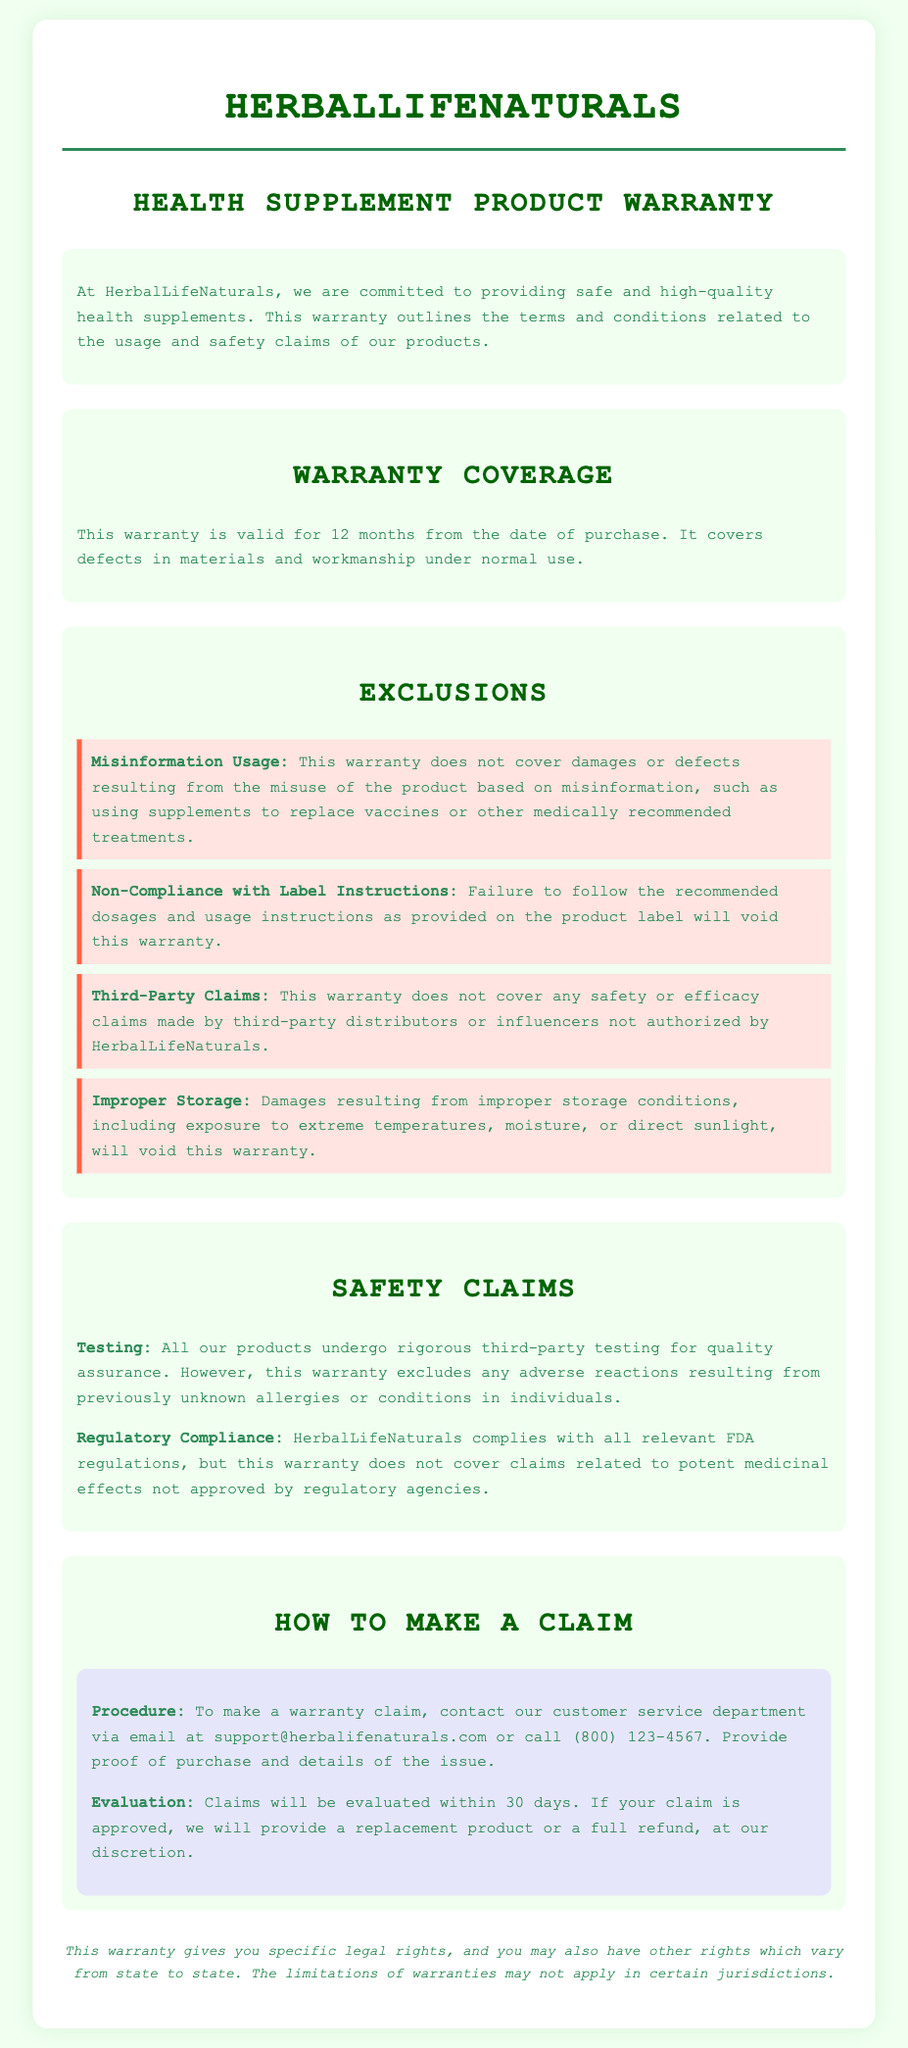What is the warranty period? The warranty period is specified in the document as 12 months from the date of purchase.
Answer: 12 months What does the warranty not cover related to misinformation? The warranty does not cover damages resulting from misuse of the product based on misinformation.
Answer: Misinformation Usage How can a customer make a warranty claim? Customers are instructed to contact the customer service department via email or phone to make a claim.
Answer: Email or call What type of claims are excluded regarding safety? The document indicates that adverse reactions from previously unknown allergies or conditions are excluded.
Answer: Adverse reactions What is the maximum evaluation time for a warranty claim? The evaluation time for a warranty claim is stated as within 30 days.
Answer: 30 days What storage conditions will void the warranty? Damages resulting from improper storage conditions will void the warranty according to the exclusions listed.
Answer: Improper Storage Which regulatory agency's compliance is mentioned? The document mentions compliance with FDA regulations.
Answer: FDA What is the consequence of not following dosage instructions? Not following dosage instructions will result in the voiding of the warranty.
Answer: Void warranty 